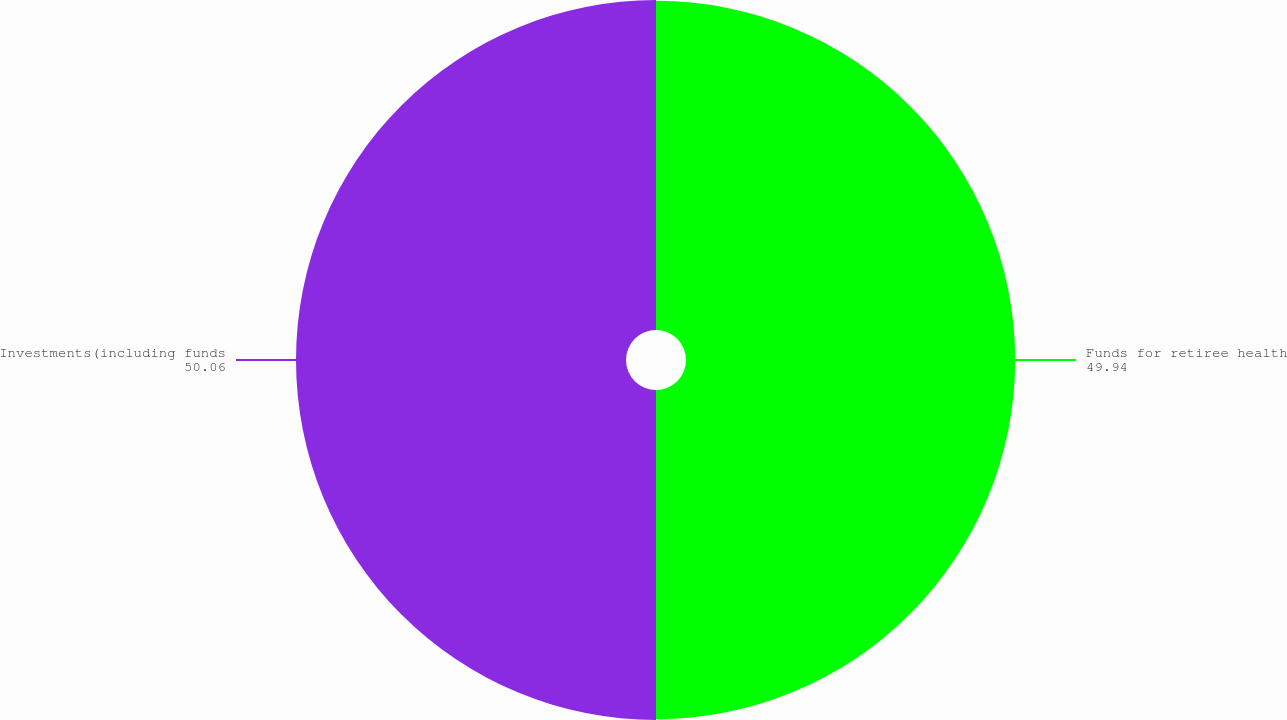Convert chart to OTSL. <chart><loc_0><loc_0><loc_500><loc_500><pie_chart><fcel>Funds for retiree health<fcel>Investments(including funds<nl><fcel>49.94%<fcel>50.06%<nl></chart> 